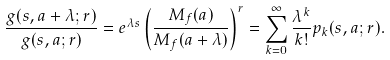Convert formula to latex. <formula><loc_0><loc_0><loc_500><loc_500>\frac { g ( s , a + \lambda ; r ) } { g ( s , a ; r ) } = e ^ { \lambda s } \left ( \frac { M _ { f } ( a ) } { M _ { f } ( a + \lambda ) } \right ) ^ { r } = \sum _ { k = 0 } ^ { \infty } \frac { \lambda ^ { k } } { k ! } p _ { k } ( s , a ; r ) .</formula> 